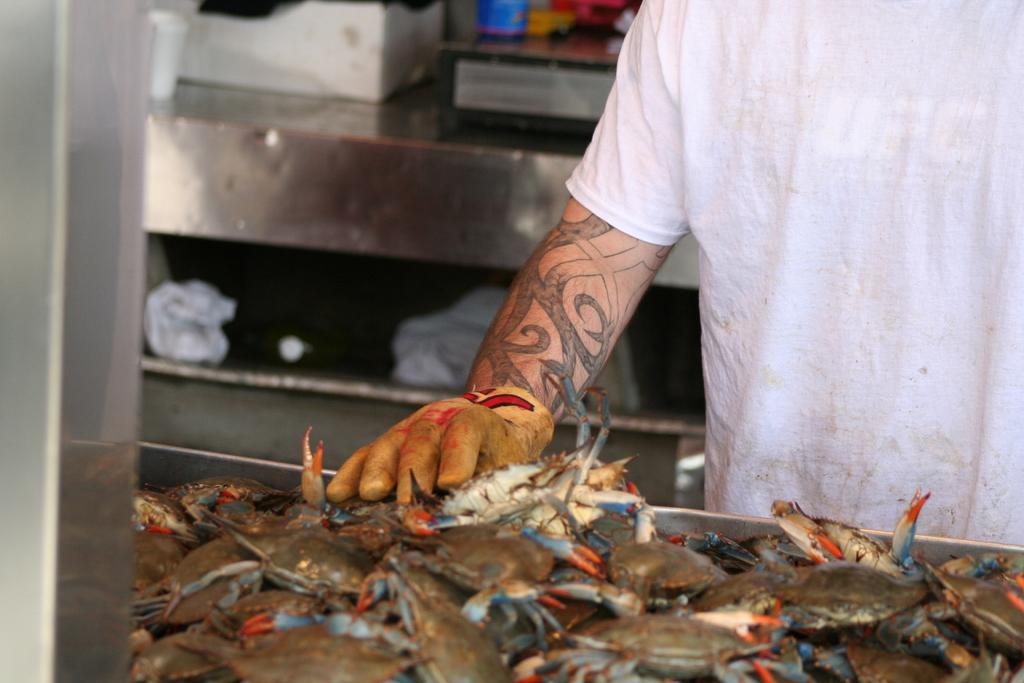What is the primary subject of the image? There is a person standing in the image. What is the person wearing on their hands? The person is wearing gloves. What can be seen in front of the person? There are fishes in front of the person. What type of furniture is visible behind the person? There are metal tables behind the person. What type of glue can be seen on the person's gloves in the image? There is no glue visible on the person's gloves in the image. How many jellyfish are swimming around the person in the image? There are no jellyfish present in the image; it features fishes instead. 